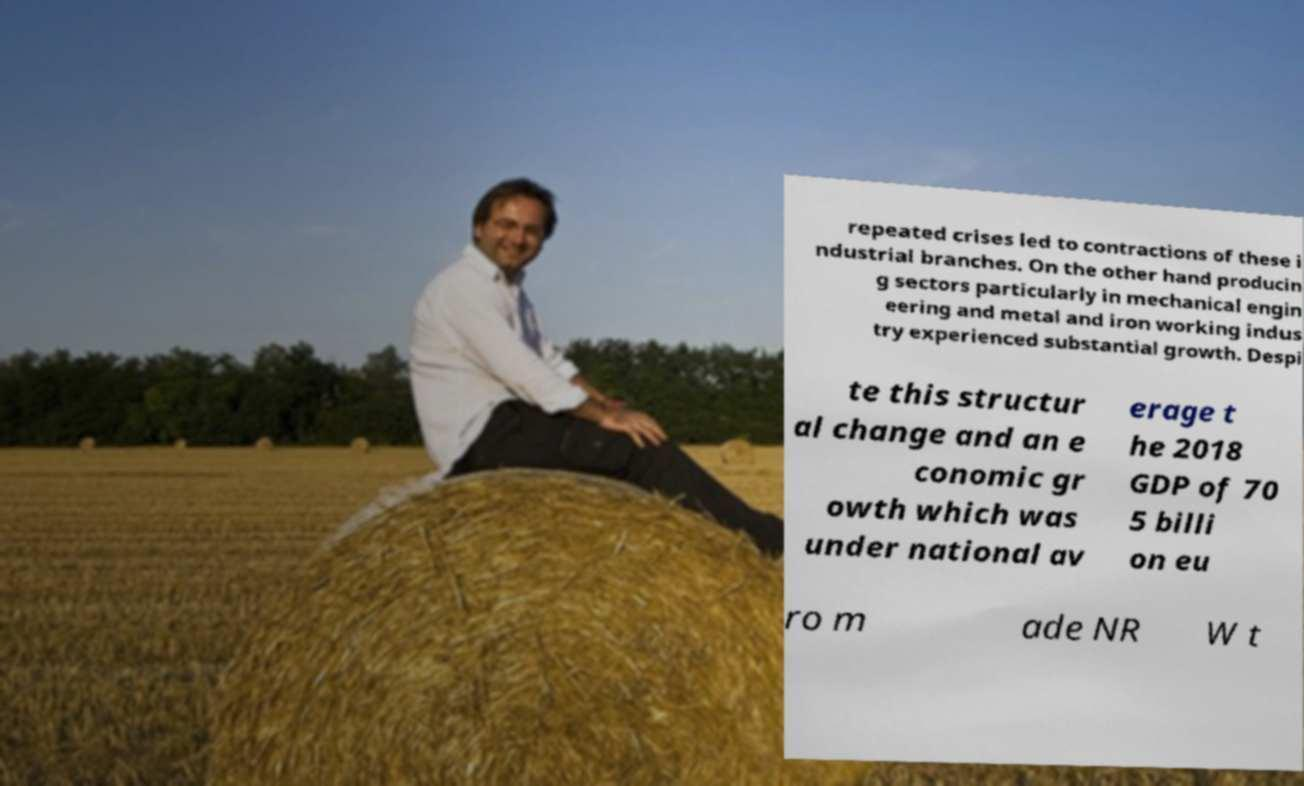Could you extract and type out the text from this image? repeated crises led to contractions of these i ndustrial branches. On the other hand producin g sectors particularly in mechanical engin eering and metal and iron working indus try experienced substantial growth. Despi te this structur al change and an e conomic gr owth which was under national av erage t he 2018 GDP of 70 5 billi on eu ro m ade NR W t 